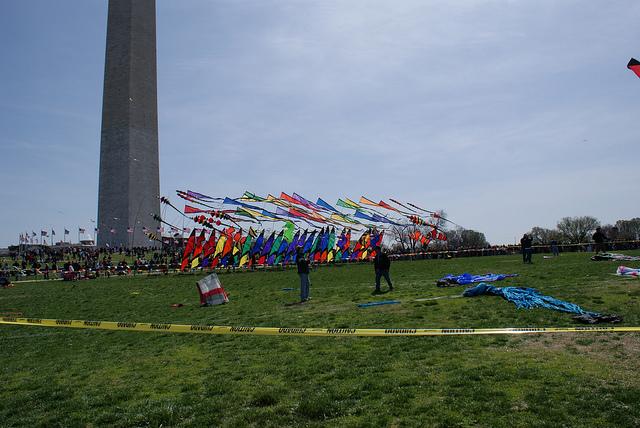What kind of tape is shown?
Keep it brief. Caution. Are the flags ceremonial in nature?
Quick response, please. Yes. What monument is in the background?
Keep it brief. Washington. 